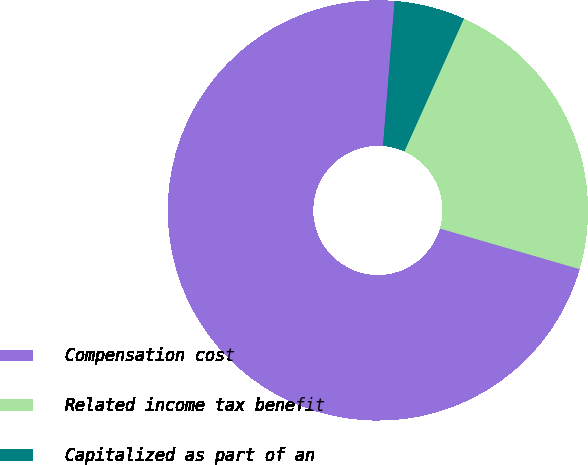<chart> <loc_0><loc_0><loc_500><loc_500><pie_chart><fcel>Compensation cost<fcel>Related income tax benefit<fcel>Capitalized as part of an<nl><fcel>71.76%<fcel>22.79%<fcel>5.44%<nl></chart> 